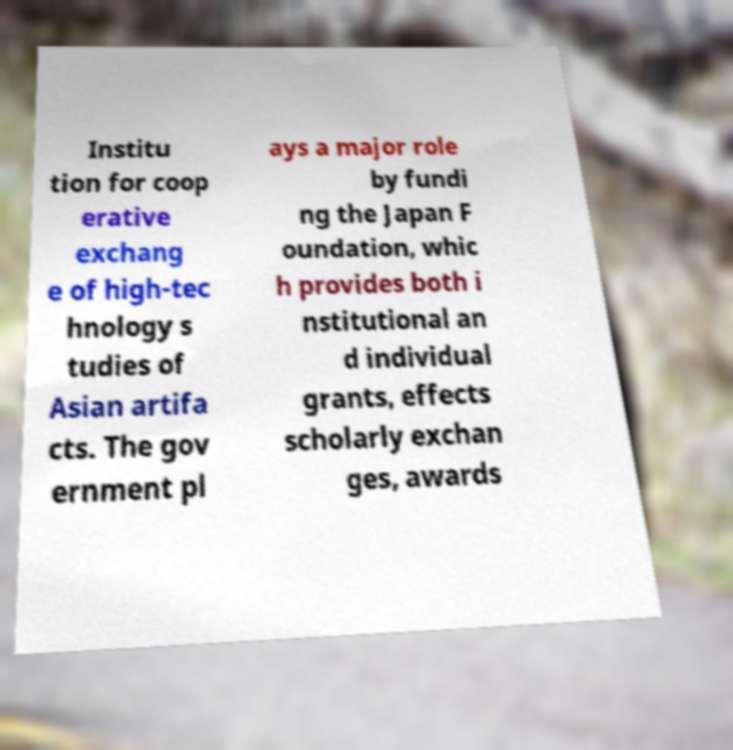Can you read and provide the text displayed in the image?This photo seems to have some interesting text. Can you extract and type it out for me? Institu tion for coop erative exchang e of high-tec hnology s tudies of Asian artifa cts. The gov ernment pl ays a major role by fundi ng the Japan F oundation, whic h provides both i nstitutional an d individual grants, effects scholarly exchan ges, awards 